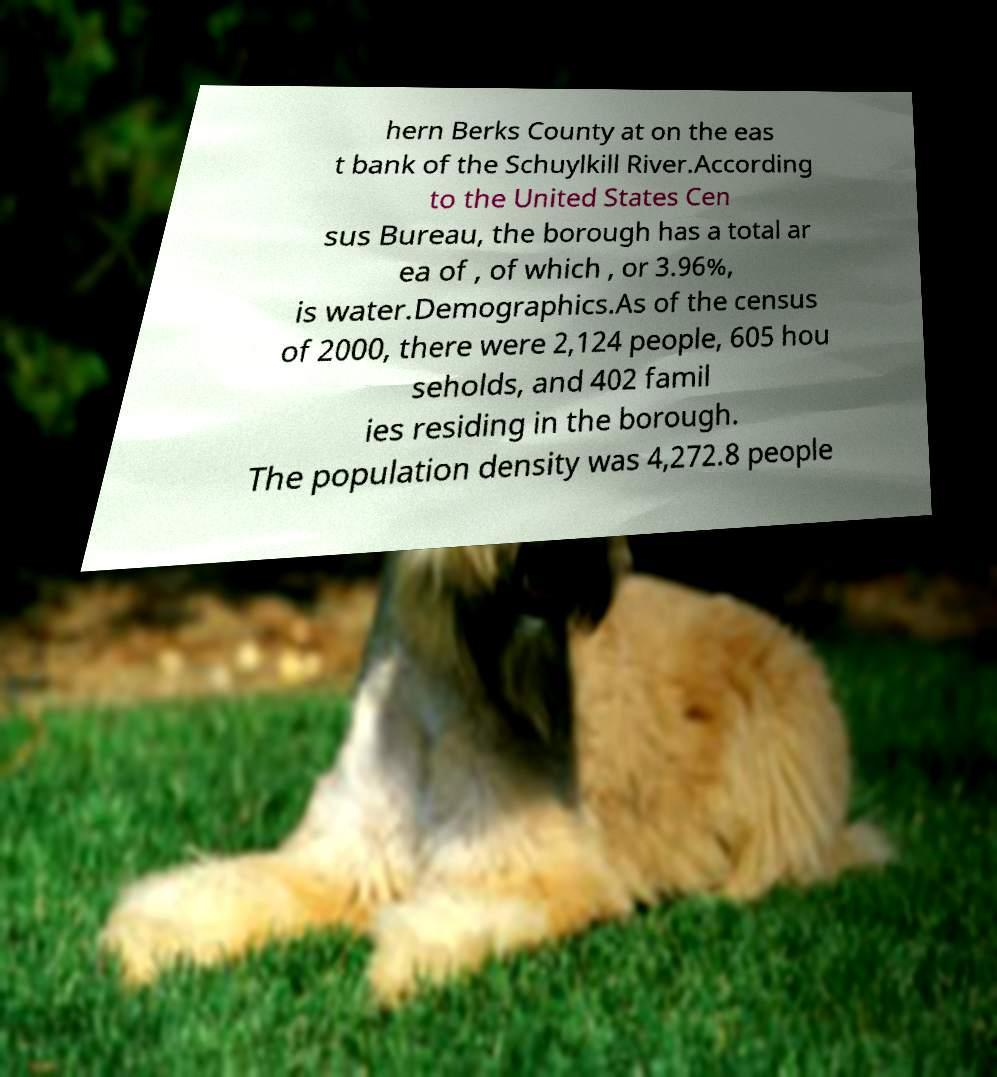Could you extract and type out the text from this image? hern Berks County at on the eas t bank of the Schuylkill River.According to the United States Cen sus Bureau, the borough has a total ar ea of , of which , or 3.96%, is water.Demographics.As of the census of 2000, there were 2,124 people, 605 hou seholds, and 402 famil ies residing in the borough. The population density was 4,272.8 people 